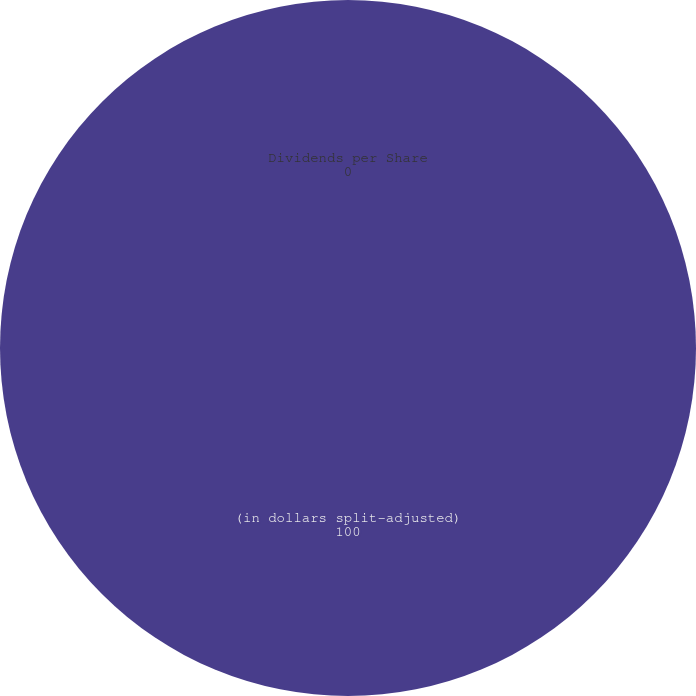Convert chart. <chart><loc_0><loc_0><loc_500><loc_500><pie_chart><fcel>(in dollars split-adjusted)<fcel>Dividends per Share<nl><fcel>100.0%<fcel>0.0%<nl></chart> 